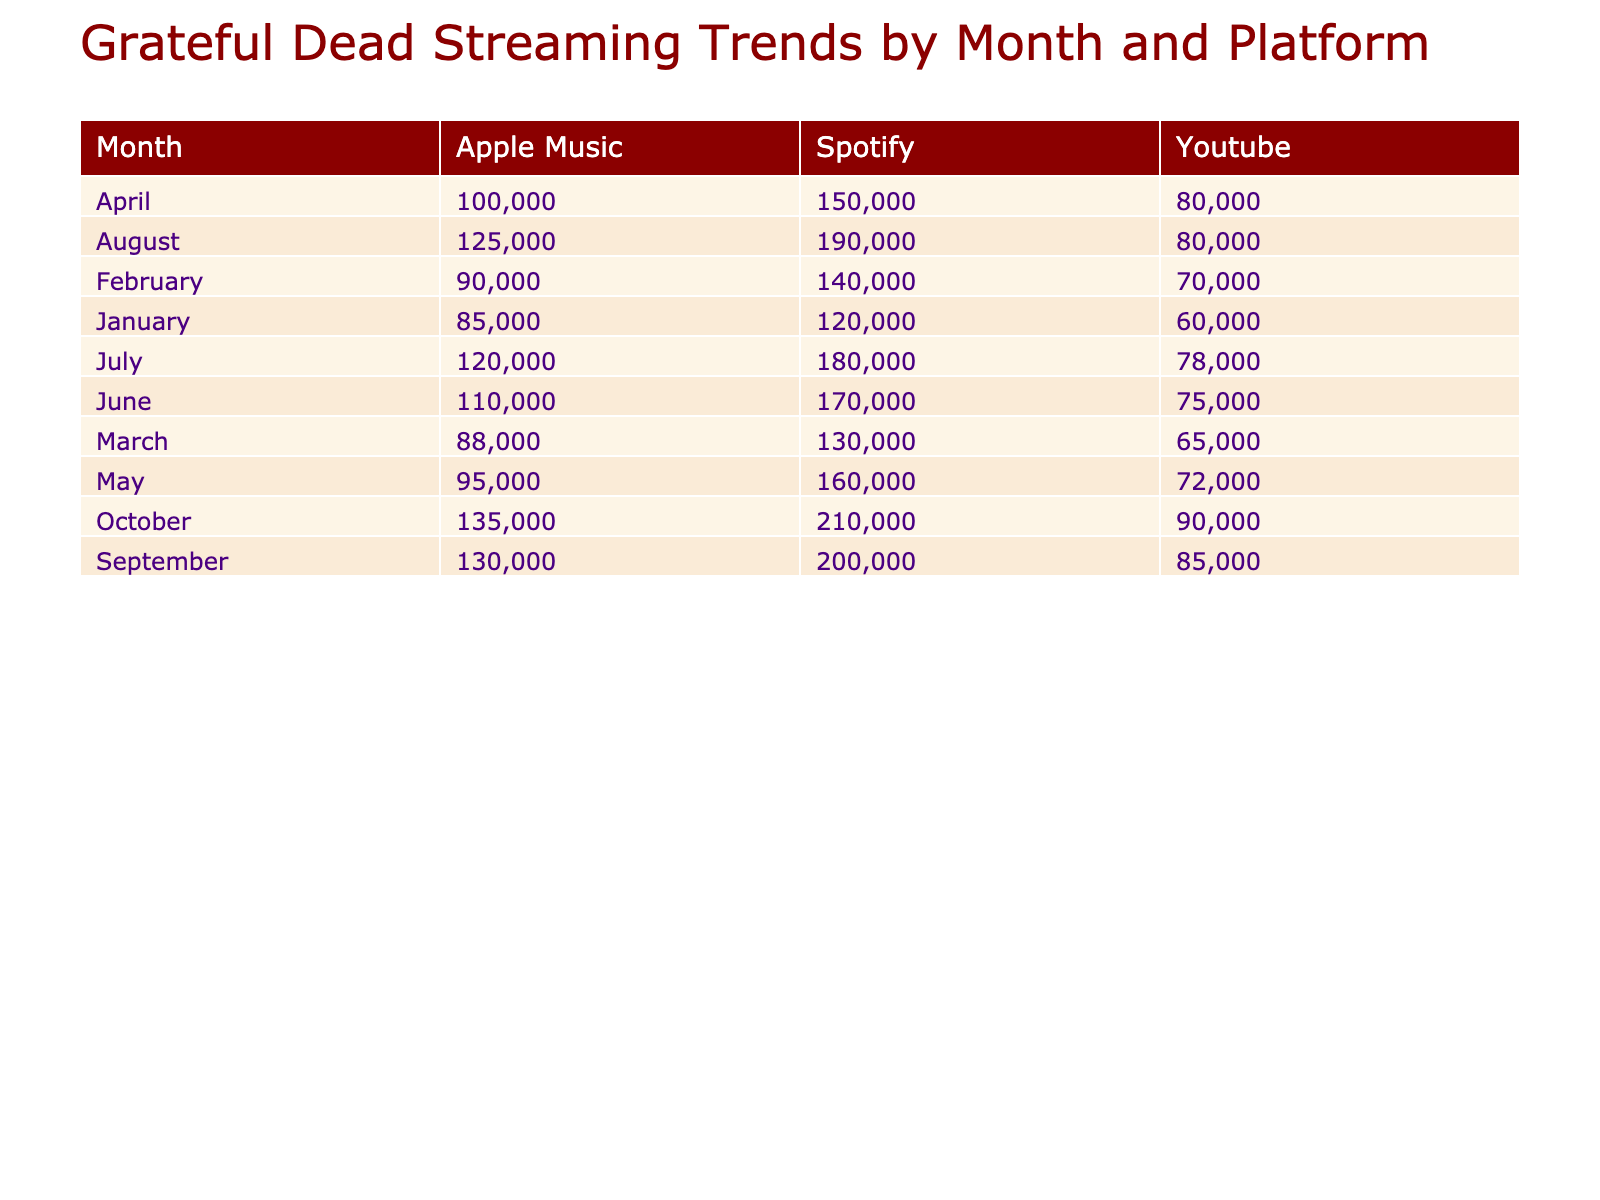What was the total number of streams for Grateful Dead music on YouTube in August? The table shows that the total streams for YouTube in August is 80,000. To find this, I look directly at the table under the "YouTube" column for "August."
Answer: 80,000 Which month had the highest total streams on Spotify? By checking the "Total Streams" under the "Spotify" column, I find that October had the highest total with 210,000 streams. I can confirm this by comparing the values for each month.
Answer: October What was the average listening duration on Apple Music for the six months listed? To find the average, I first note the listening durations for Apple Music across the six months: 50, 52, 49, 55, 53, 57. Summing these gives 316 minutes, and dividing by 6 gives an average of approximately 52.67 minutes.
Answer: 52.67 Did January have more unique listeners on Spotify than on Apple Music? The table indicates that January had 30,000 unique listeners on Spotify and 22,000 on Apple Music. Since 30,000 is greater than 22,000, the answer is yes.
Answer: Yes Which platform had the lowest average listening duration in March? The "Average Listening Duration" for March on Spotify is 46 minutes, on Apple Music is 49 minutes, and on YouTube is 32 minutes. YouTube has the lowest average at 32 minutes.
Answer: YouTube If we look at the total streams for all platforms in April, which platform contributed the most? In April, Spotify contributed 150,000 streams, Apple Music contributed 100,000 streams, and YouTube contributed 80,000 streams. Adding these gives a total of 330,000 streams, with Spotify being the highest contributor at 150,000.
Answer: Spotify How much did the total streams on Apple Music increase from January to October? The total streams for Apple Music in January are 85,000 and in October are 135,000. The difference in streams is 135,000 - 85,000 = 50,000, indicating an increase.
Answer: 50,000 Was the total number of unique listeners on Spotify always increasing each month? Upon examining the "Unique Listeners" in the Spotify column, I find the values for each month: 30,000, 32,000, 31,000, 35,000, 36,000, 37,000, 38,000, 40,000, 42,000, and 43,000. The pattern shows an increase with one decrease in March, indicating it wasn't always increasing.
Answer: No In which month did YouTube have its maximum total streams? Checking the `Total Streams` for YouTube, the highest number is 85,000 in September. Therefore, the month with the maximum streams for YouTube is September.
Answer: September 